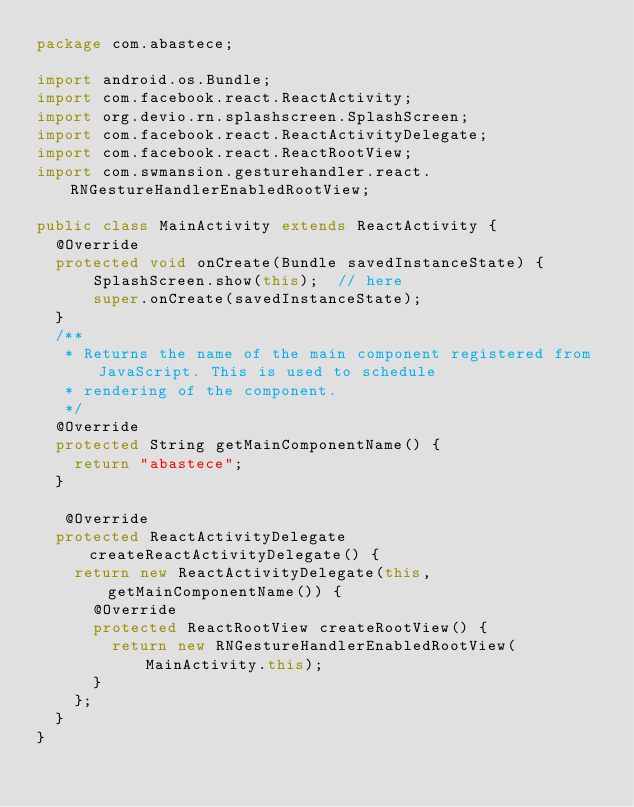Convert code to text. <code><loc_0><loc_0><loc_500><loc_500><_Java_>package com.abastece;

import android.os.Bundle;
import com.facebook.react.ReactActivity;
import org.devio.rn.splashscreen.SplashScreen;
import com.facebook.react.ReactActivityDelegate;
import com.facebook.react.ReactRootView;
import com.swmansion.gesturehandler.react.RNGestureHandlerEnabledRootView;

public class MainActivity extends ReactActivity {
  @Override
  protected void onCreate(Bundle savedInstanceState) {
      SplashScreen.show(this);  // here
      super.onCreate(savedInstanceState);
  }
  /**
   * Returns the name of the main component registered from JavaScript. This is used to schedule
   * rendering of the component.
   */
  @Override
  protected String getMainComponentName() {
    return "abastece";
  }

   @Override
  protected ReactActivityDelegate createReactActivityDelegate() {
    return new ReactActivityDelegate(this, getMainComponentName()) {
      @Override
      protected ReactRootView createRootView() {
        return new RNGestureHandlerEnabledRootView(MainActivity.this);
      }
    };
  }
}

</code> 